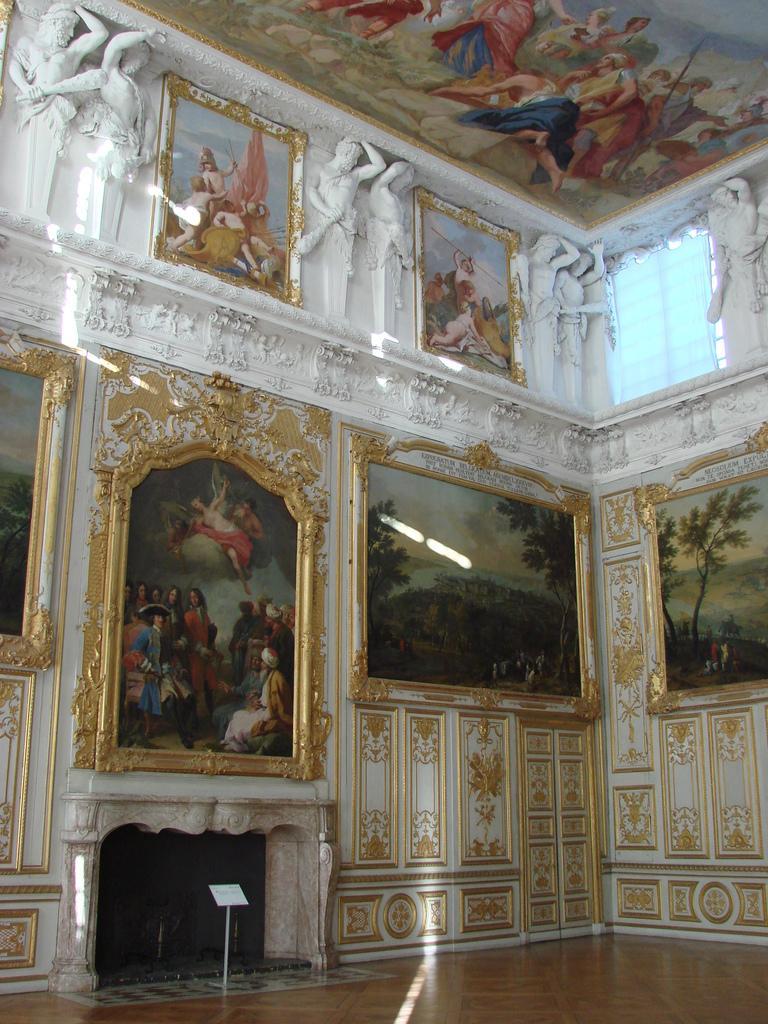In one or two sentences, can you explain what this image depicts? In this image we can see an inner view of a building containing some photo frames on the walls, the sculptures, a window with a curtain, a roof with some pictures and a speaker stand which is placed on the floor. 